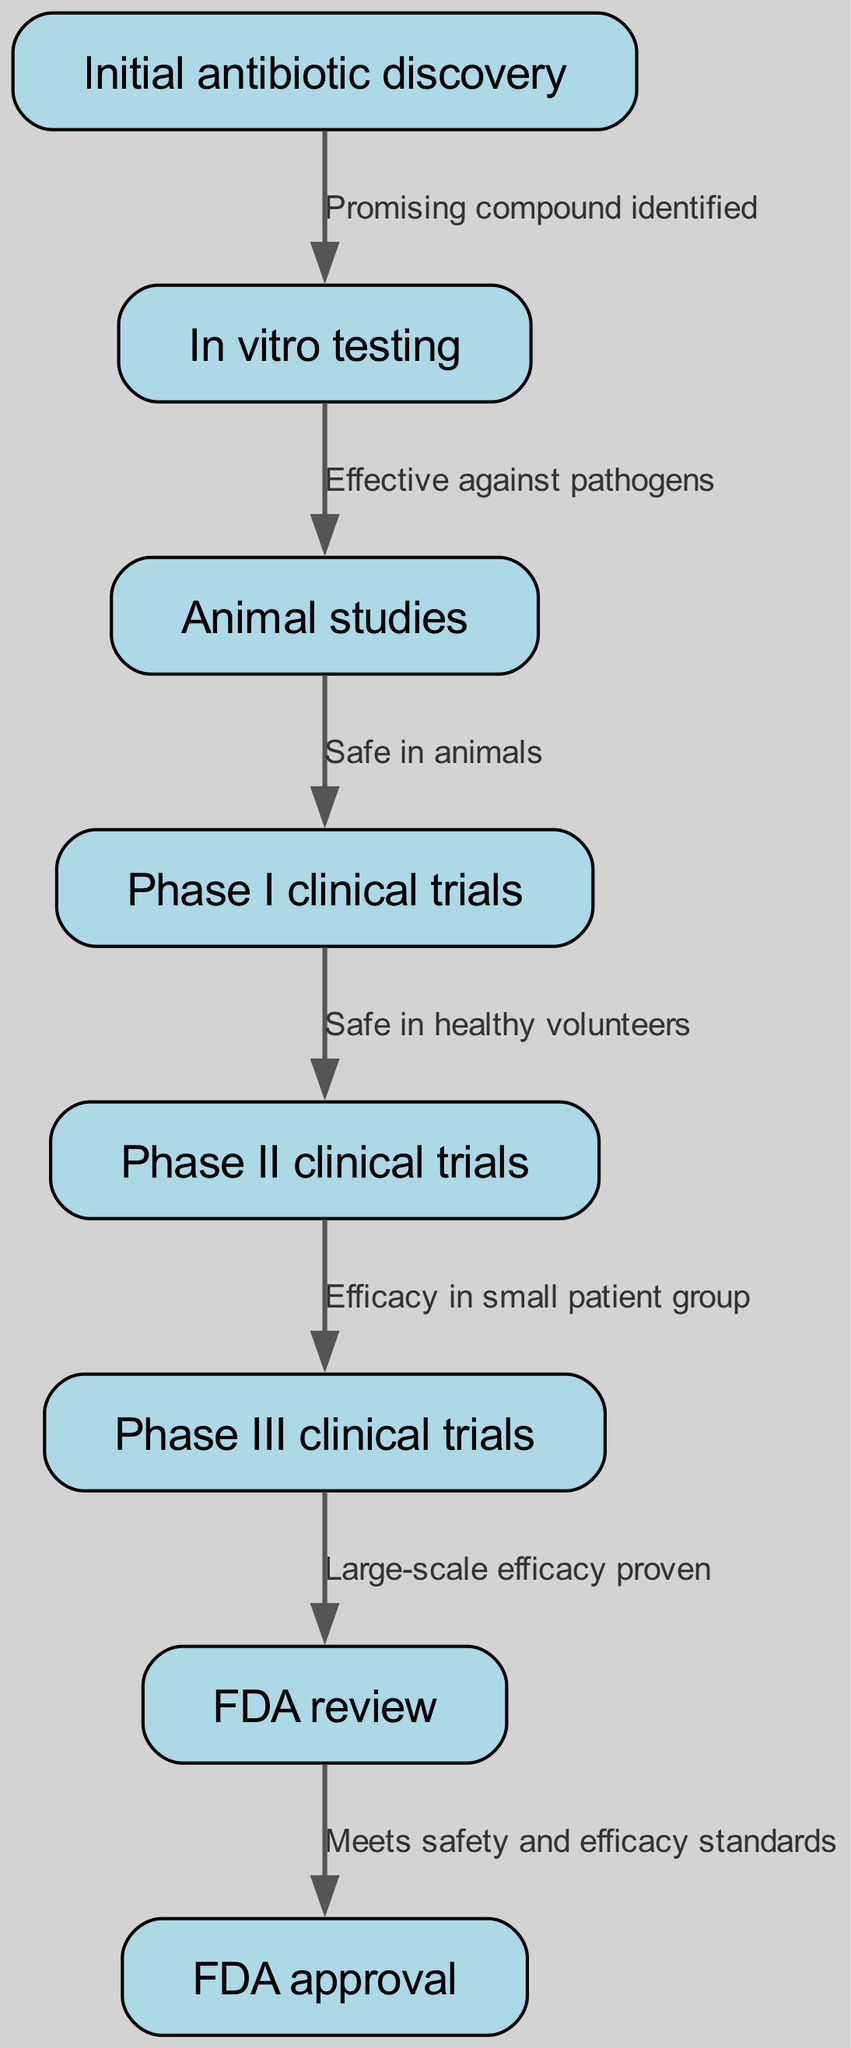What's the first step in the clinical trial process? The diagram indicates that the first step is "Initial antibiotic discovery." I can identify this by looking at the first node in the flow.
Answer: Initial antibiotic discovery How many total nodes are present in the diagram? By counting the nodes listed in the data, there are eight total nodes, which are steps in the clinical trial process.
Answer: 8 What edge connects "Animal studies" to "Phase I clinical trials"? The direct connection is shown in the diagram by the edge labeled "Safe in animals." This indicates a successful transition from animal studies to clinical trials.
Answer: Safe in animals What is the prerequisite for "Phase II clinical trials"? According to the diagram, "Phase II clinical trials" follows "Phase I clinical trials" and is contingent upon being "Safe in healthy volunteers," as shown on the edge connecting them.
Answer: Safe in healthy volunteers What is the relationship between "Phase III clinical trials" and "FDA approval"? The relationship is characterized by the edge that indicates that "Large-scale efficacy proven" during Phase III clinical trials is a requirement before seeking FDA approval. Therefore, successful Phase III trials lead to FDA review and potentially approval.
Answer: Large-scale efficacy proven What must be demonstrated for the FDA to consider approval of a new antibiotic? The diagram specifies that the antibotic must "Meet safety and efficacy standards" during the FDA review to proceed to approval, which is directly stated in the edge connecting these two nodes.
Answer: Meet safety and efficacy standards Identify the terminal node of the flow chart. The terminal node is the last step in the process listed in the diagram, which represents the final outcome of the entire process. It can be seen as the conclusive step after FDA review.
Answer: FDA approval What phase follows "In vitro testing"? The flow from "In vitro testing" leads directly to "Animal studies," indicating that animal studies are the next step after identifying an effective compound in vitro.
Answer: Animal studies 